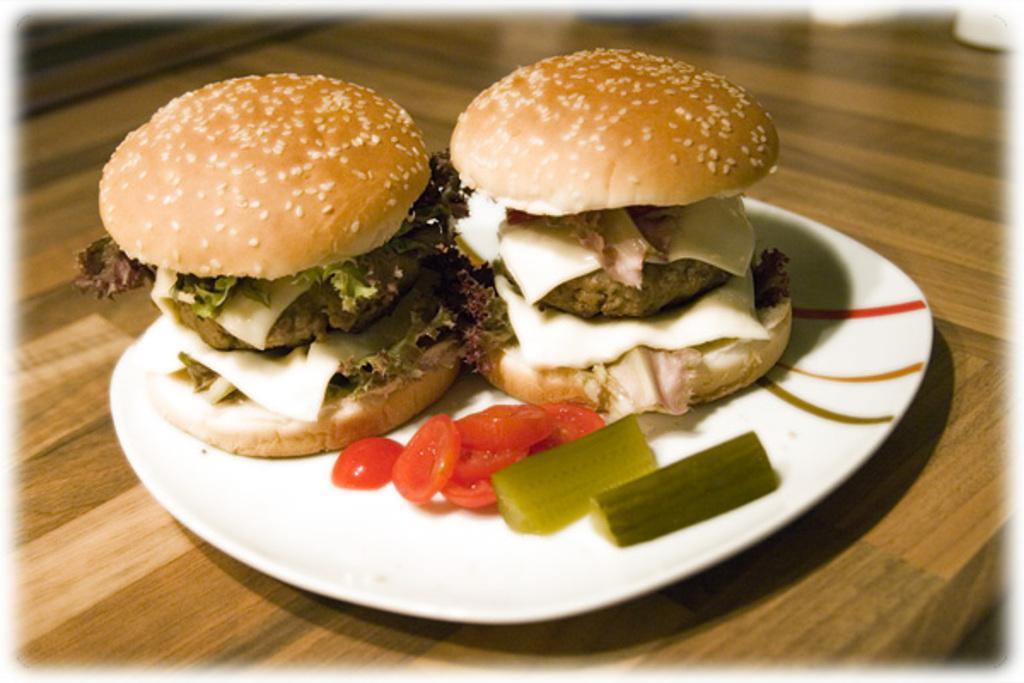In one or two sentences, can you explain what this image depicts? In this image I can see a plate which consists of two burgers and a few slices of tomato. This plate is placed on a table. 